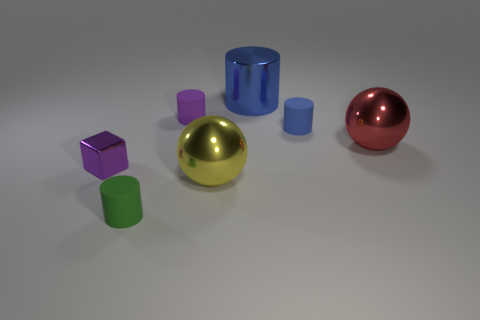Subtract all blue cylinders. How many were subtracted if there are1blue cylinders left? 1 Subtract 1 cylinders. How many cylinders are left? 3 Add 3 large red metallic spheres. How many objects exist? 10 Subtract all spheres. How many objects are left? 5 Add 3 big red objects. How many big red objects are left? 4 Add 5 red balls. How many red balls exist? 6 Subtract 0 gray blocks. How many objects are left? 7 Subtract all green rubber things. Subtract all yellow balls. How many objects are left? 5 